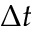<formula> <loc_0><loc_0><loc_500><loc_500>\Delta t</formula> 